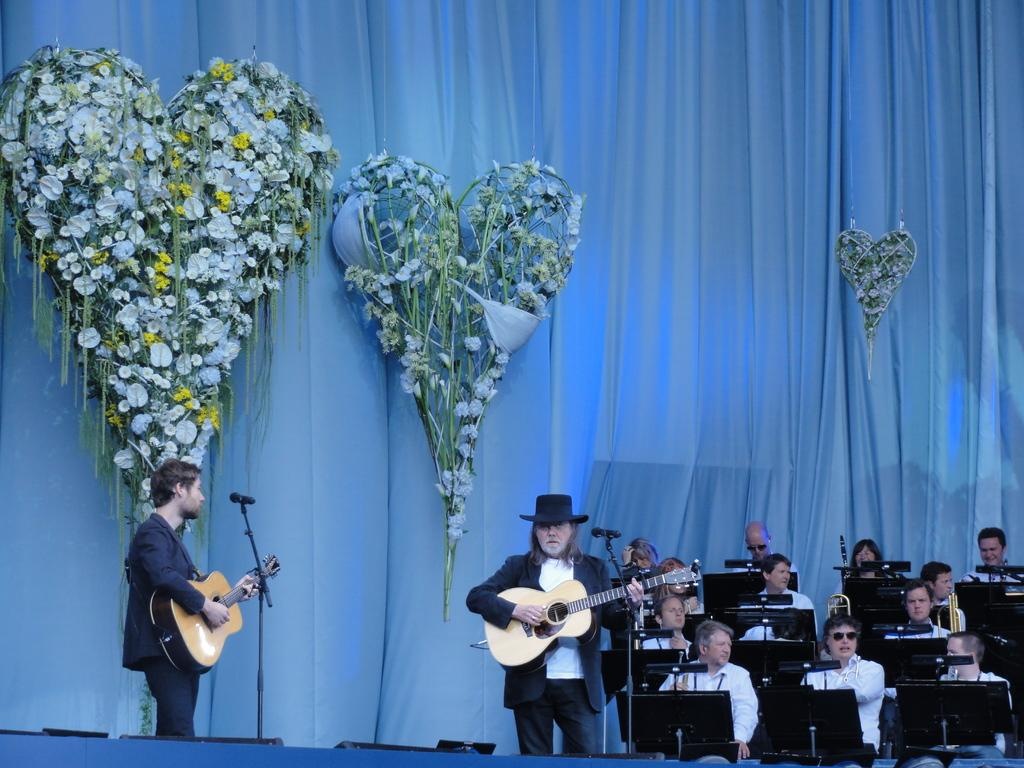What are the people in the image doing? There are people sitting on chairs in the image. Are there any other people in the image besides those sitting on chairs? Yes, there are two men standing in the image. What are the two men holding in their hands? The two men are holding guitars in their hands. Can you see a hen paying attention to the musicians in the image? There is no hen present in the image, so it is not possible to determine how many people are giving their attention to the musicians in the image? What is the main subject of the image? The main subject of the image is a car. Where is the car located in the image? The car is parked on the street. What can be seen on both sides of the street in the image? There are trees on both sides of the street. What is visible in the background of the image? The sky is visible in the image. Reasoning: Let's think step by step in order to produce the conversation. We start by identifying the main subject of the image, which is the car. Then, we describe the car's location, noting that it is parked on the street. Next, we mention the presence of trees on both sides of the street. Finally, we acknowledge the presence of the sky in the background. Each question is designed to elicit a specific detail about the image that is known from the provided facts. Absurd Question/Answer: Can you see a parrot dancing on the car in the image? There is no parrot or dancing activity present in the image. 